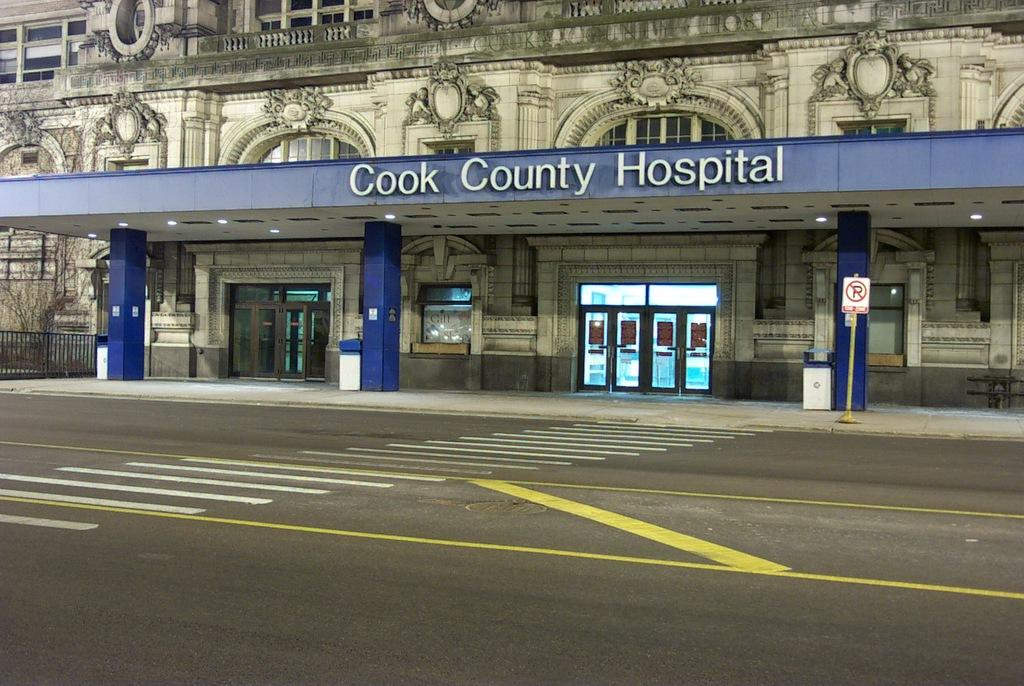<image>
Write a terse but informative summary of the picture. An entry way with doors to the Cook County Hospital 